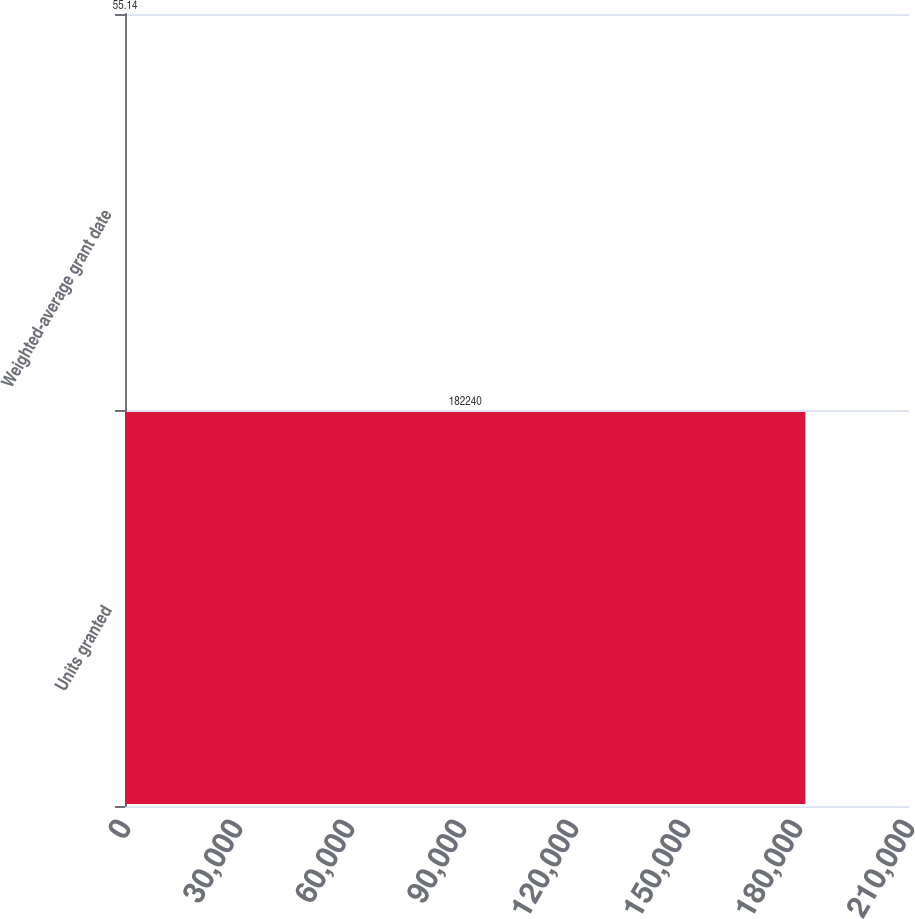Convert chart. <chart><loc_0><loc_0><loc_500><loc_500><bar_chart><fcel>Units granted<fcel>Weighted-average grant date<nl><fcel>182240<fcel>55.14<nl></chart> 